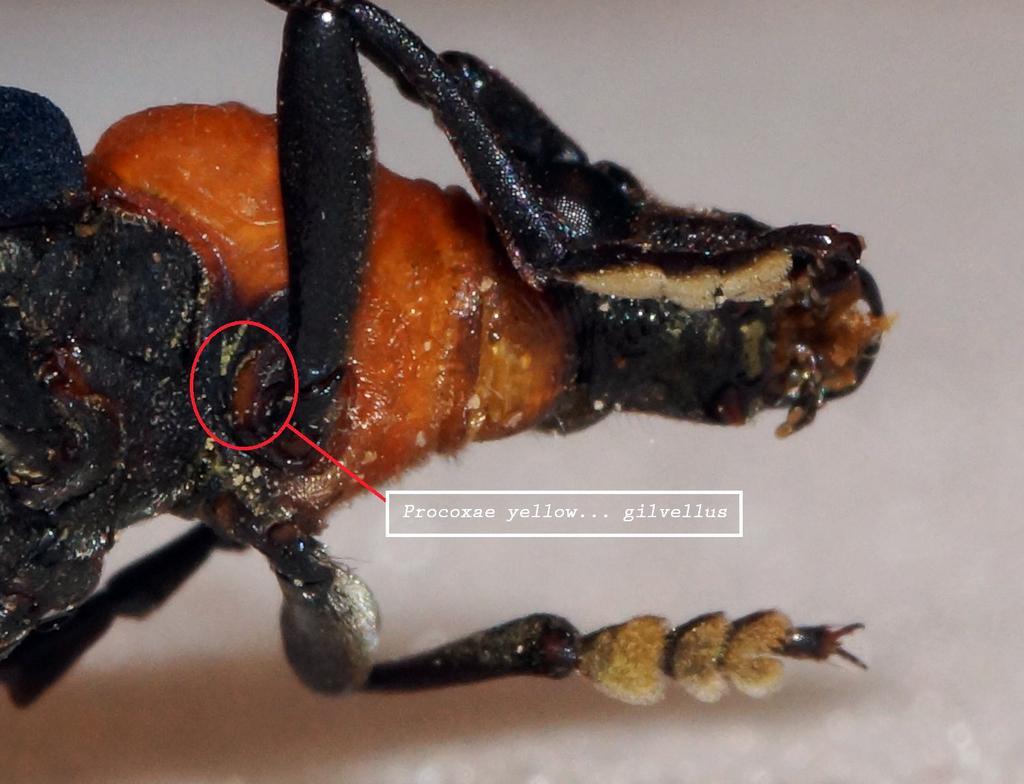Please provide a concise description of this image. In this picture there is an insect. At the back there is a white background. In the middle of the image there is a text and there is a red color circle mark on the insect and the insect is in black and in orange color. 